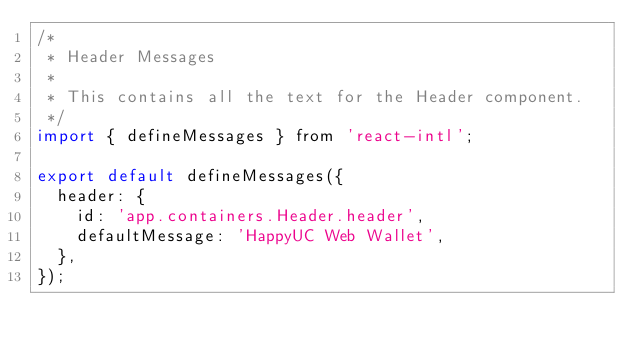Convert code to text. <code><loc_0><loc_0><loc_500><loc_500><_JavaScript_>/*
 * Header Messages
 *
 * This contains all the text for the Header component.
 */
import { defineMessages } from 'react-intl';

export default defineMessages({
  header: {
    id: 'app.containers.Header.header',
    defaultMessage: 'HappyUC Web Wallet',
  },
});
</code> 